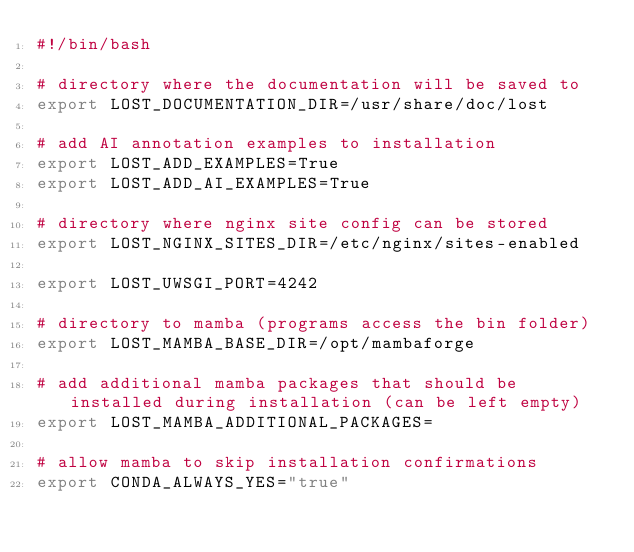Convert code to text. <code><loc_0><loc_0><loc_500><loc_500><_Bash_>#!/bin/bash

# directory where the documentation will be saved to
export LOST_DOCUMENTATION_DIR=/usr/share/doc/lost

# add AI annotation examples to installation
export LOST_ADD_EXAMPLES=True
export LOST_ADD_AI_EXAMPLES=True

# directory where nginx site config can be stored
export LOST_NGINX_SITES_DIR=/etc/nginx/sites-enabled

export LOST_UWSGI_PORT=4242

# directory to mamba (programs access the bin folder)
export LOST_MAMBA_BASE_DIR=/opt/mambaforge

# add additional mamba packages that should be installed during installation (can be left empty)
export LOST_MAMBA_ADDITIONAL_PACKAGES=

# allow mamba to skip installation confirmations
export CONDA_ALWAYS_YES="true"
</code> 